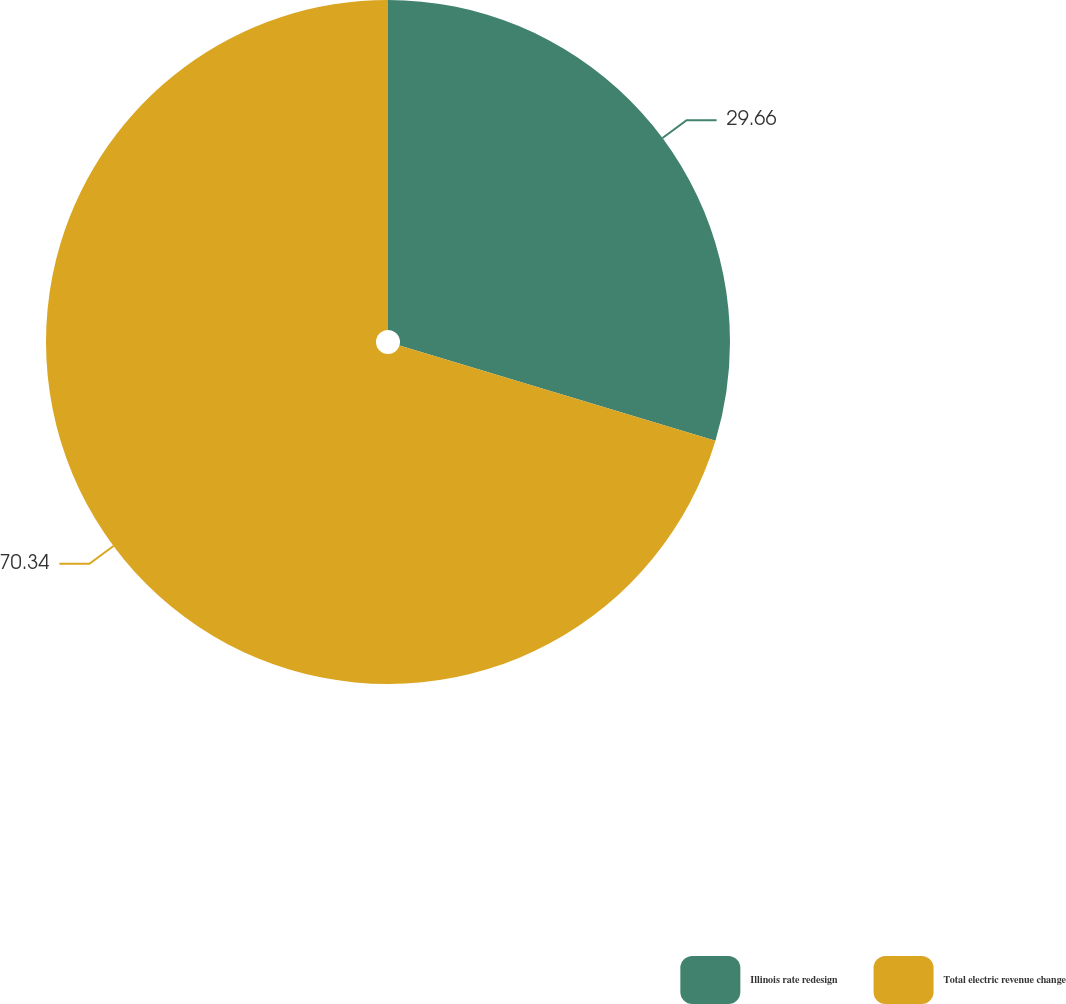Convert chart to OTSL. <chart><loc_0><loc_0><loc_500><loc_500><pie_chart><fcel>Illinois rate redesign<fcel>Total electric revenue change<nl><fcel>29.66%<fcel>70.34%<nl></chart> 